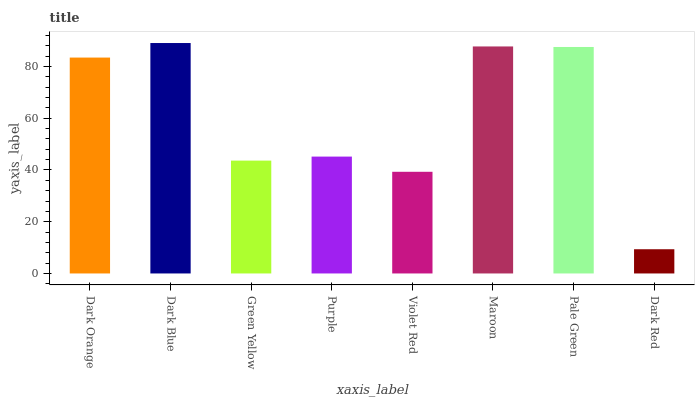Is Dark Red the minimum?
Answer yes or no. Yes. Is Dark Blue the maximum?
Answer yes or no. Yes. Is Green Yellow the minimum?
Answer yes or no. No. Is Green Yellow the maximum?
Answer yes or no. No. Is Dark Blue greater than Green Yellow?
Answer yes or no. Yes. Is Green Yellow less than Dark Blue?
Answer yes or no. Yes. Is Green Yellow greater than Dark Blue?
Answer yes or no. No. Is Dark Blue less than Green Yellow?
Answer yes or no. No. Is Dark Orange the high median?
Answer yes or no. Yes. Is Purple the low median?
Answer yes or no. Yes. Is Pale Green the high median?
Answer yes or no. No. Is Pale Green the low median?
Answer yes or no. No. 